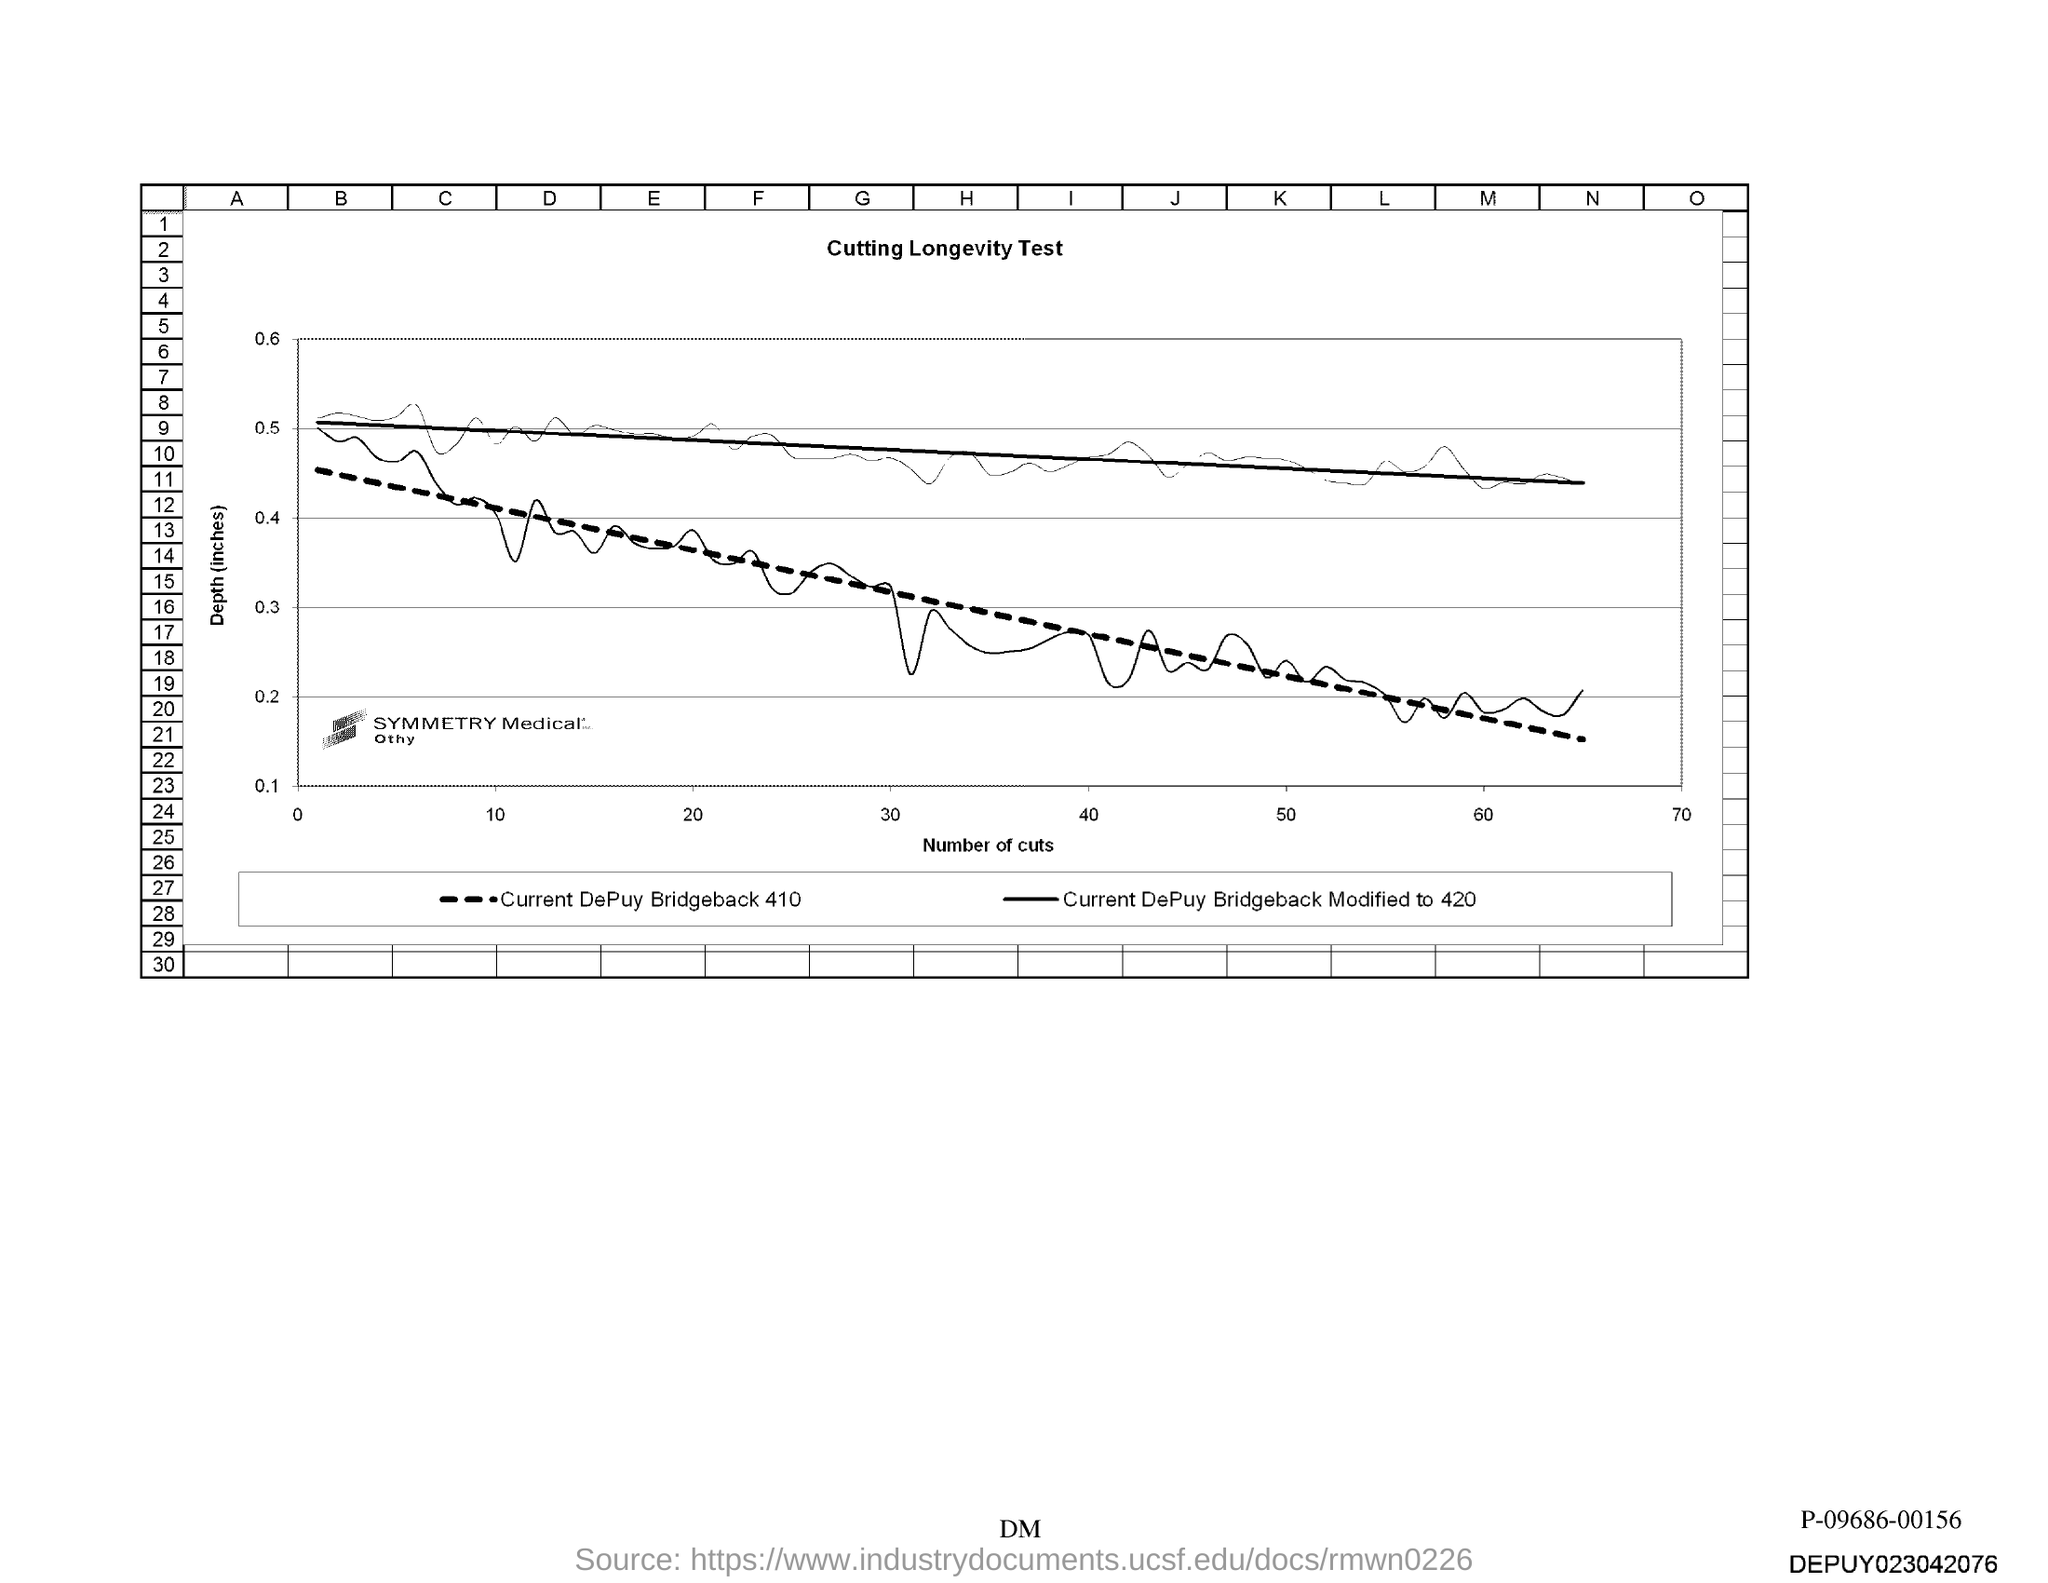What is given in the x-axis of the graph?
Offer a very short reply. Number of cuts. 